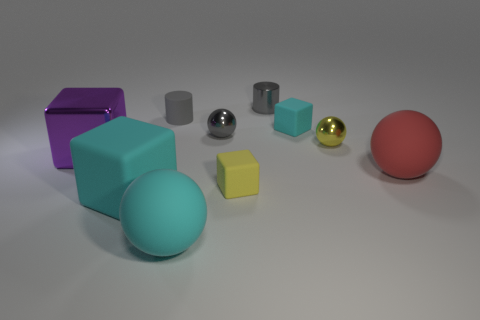Subtract all rubber cubes. How many cubes are left? 1 Subtract 3 cubes. How many cubes are left? 1 Subtract all cyan cubes. How many cubes are left? 2 Subtract all purple balls. How many red cylinders are left? 0 Subtract all spheres. How many objects are left? 6 Subtract all red blocks. Subtract all yellow spheres. How many blocks are left? 4 Subtract all big red rubber things. Subtract all tiny objects. How many objects are left? 3 Add 9 metal cylinders. How many metal cylinders are left? 10 Add 1 tiny gray rubber things. How many tiny gray rubber things exist? 2 Subtract 1 gray balls. How many objects are left? 9 